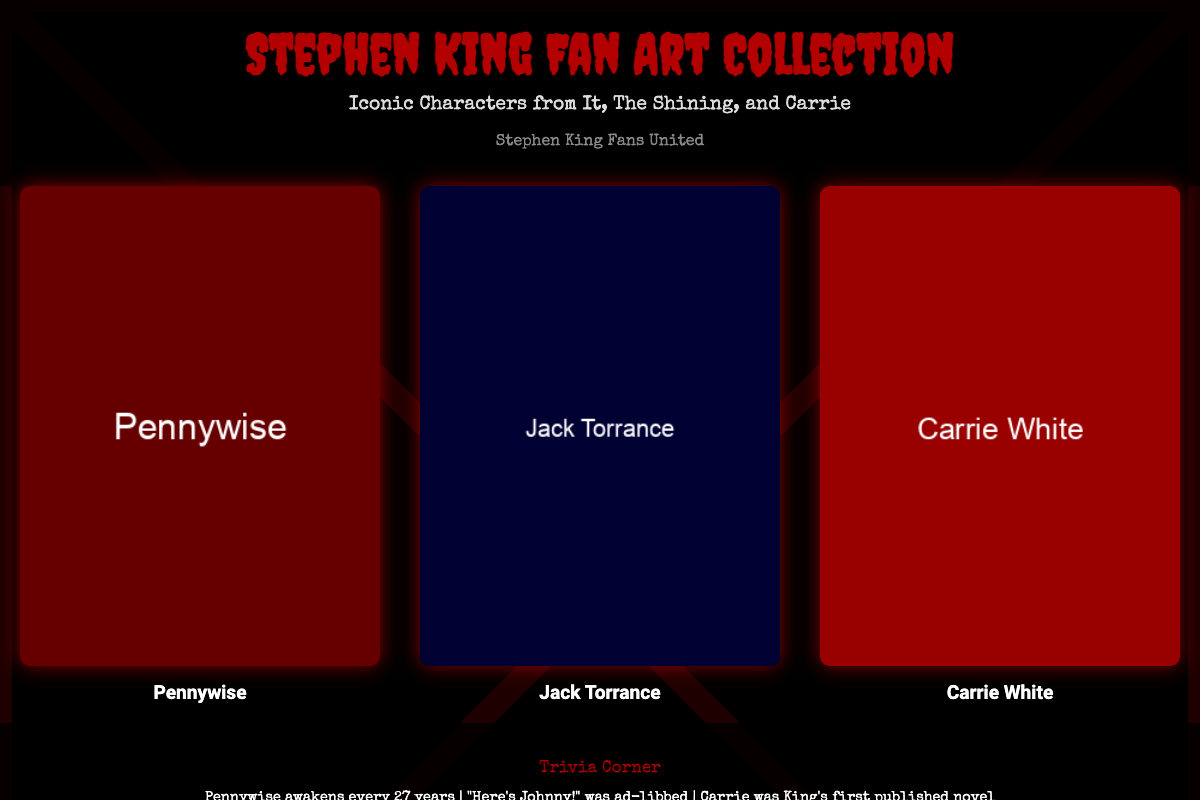What is the title of the fan art collection? The title is prominently displayed at the top of the document cover, indicating the main focus of the collection.
Answer: Stephen King Fan Art Collection Which characters are featured in the fan art collection? The document lists the characters showcased in the illustrations, highlighting the diverse focus of the art.
Answer: Pennywise, Jack Torrance, Carrie White What color is used for the title text? The color of the title is specifically mentioned in the style settings, enhancing its visibility against the background.
Answer: Red What is the next release date for the Stephen King novella? The countdown section provides specific upcoming dates for releases important to fans.
Answer: October 31, 2023 Which novel was Stephen King's first published work? The trivia corner references this significant aspect of King's writing history.
Answer: Carrie How many years does Pennywise awaken? The trivia provides a specific detail about the character's cycle, highlighting a key plot element from "It."
Answer: 27 years What is the background color of the document? The overall theme and mood are influenced by the background color choices made in the design of the cover.
Answer: Black Who is the author of this fan art collection? The author is indicated in the cover, establishing the community or group behind this project.
Answer: Stephen King Fans United 